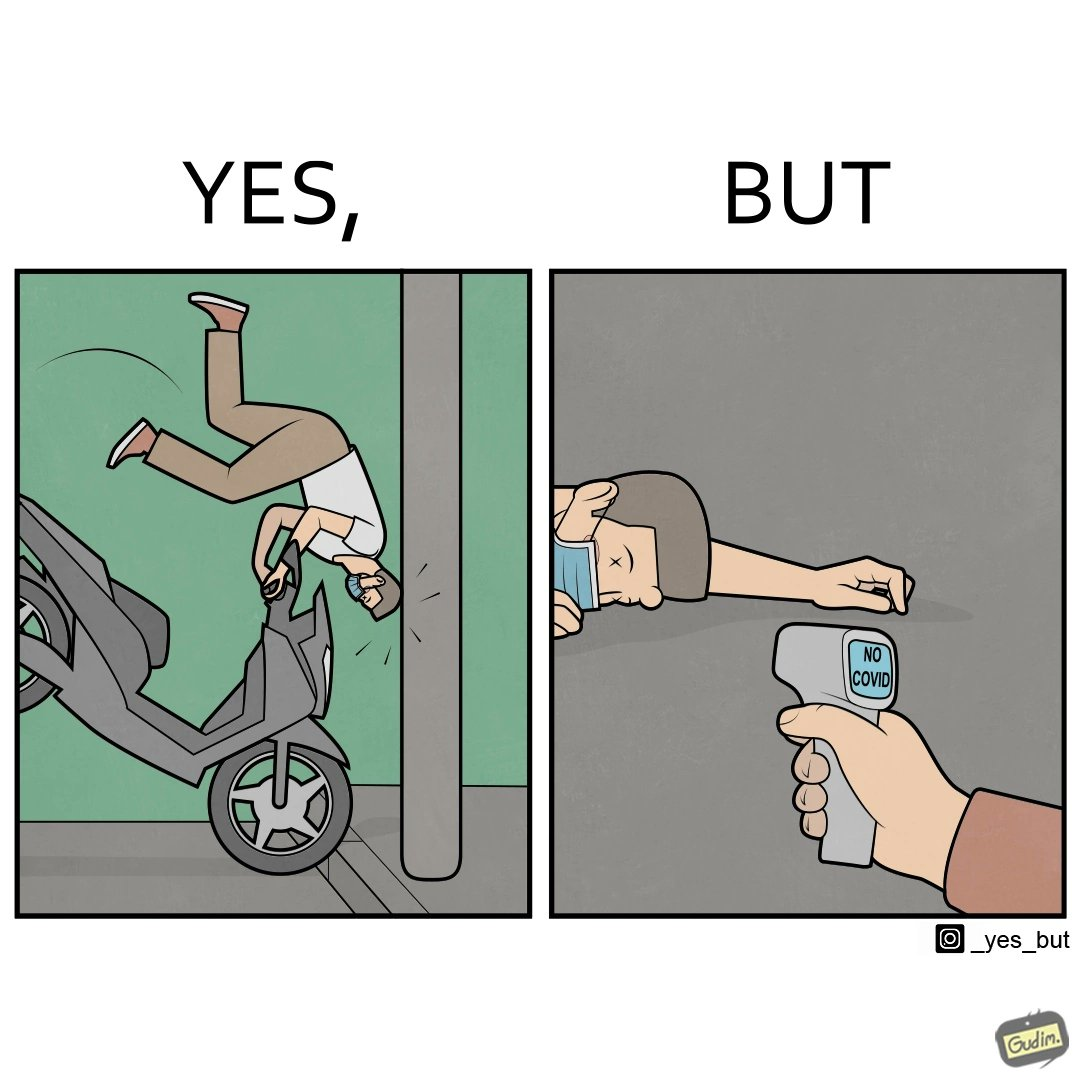What does this image depict? the irony in the image comes from people trying to avoid covid, where a injured person is scanned for covid before they get help. 